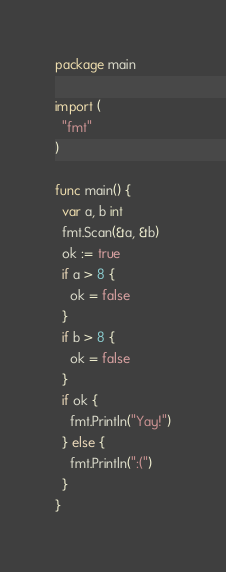Convert code to text. <code><loc_0><loc_0><loc_500><loc_500><_Go_>package main

import (
  "fmt"
)

func main() {
  var a, b int
  fmt.Scan(&a, &b)
  ok := true
  if a > 8 {
    ok = false
  }
  if b > 8 {
    ok = false
  }
  if ok {
    fmt.Println("Yay!")
  } else {
    fmt.Println(":(")
  }
}</code> 